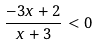<formula> <loc_0><loc_0><loc_500><loc_500>\frac { - 3 x + 2 } { x + 3 } < 0</formula> 